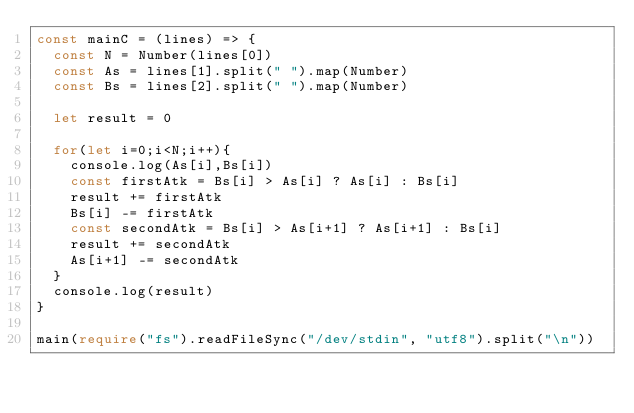<code> <loc_0><loc_0><loc_500><loc_500><_TypeScript_>const mainC = (lines) => {
  const N = Number(lines[0])
  const As = lines[1].split(" ").map(Number)
  const Bs = lines[2].split(" ").map(Number)
  
  let result = 0
  
  for(let i=0;i<N;i++){
    console.log(As[i],Bs[i])
    const firstAtk = Bs[i] > As[i] ? As[i] : Bs[i]
    result += firstAtk
    Bs[i] -= firstAtk
    const secondAtk = Bs[i] > As[i+1] ? As[i+1] : Bs[i]
    result += secondAtk
    As[i+1] -= secondAtk
  }
  console.log(result)
}

main(require("fs").readFileSync("/dev/stdin", "utf8").split("\n"))</code> 